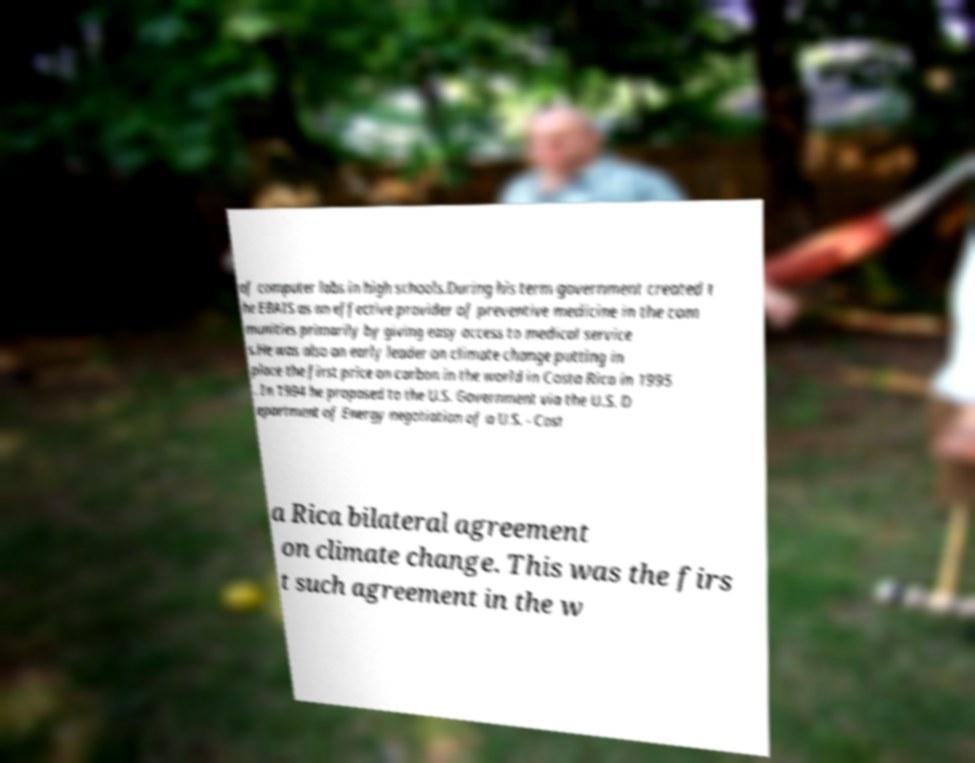Please read and relay the text visible in this image. What does it say? of computer labs in high schools.During his term government created t he EBAIS as an effective provider of preventive medicine in the com munities primarily by giving easy access to medical service s.He was also an early leader on climate change putting in place the first price on carbon in the world in Costa Rica in 1995 . In 1994 he proposed to the U.S. Government via the U.S. D epartment of Energy negotiation of a U.S. - Cost a Rica bilateral agreement on climate change. This was the firs t such agreement in the w 